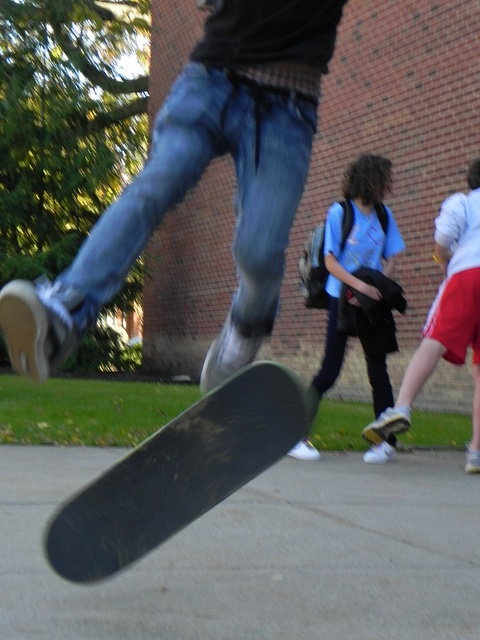Describe the objects in this image and their specific colors. I can see people in black, navy, blue, and gray tones, skateboard in black, gray, and purple tones, people in black, lightblue, gray, and blue tones, people in black, brown, darkgray, maroon, and gray tones, and backpack in black, gray, and navy tones in this image. 